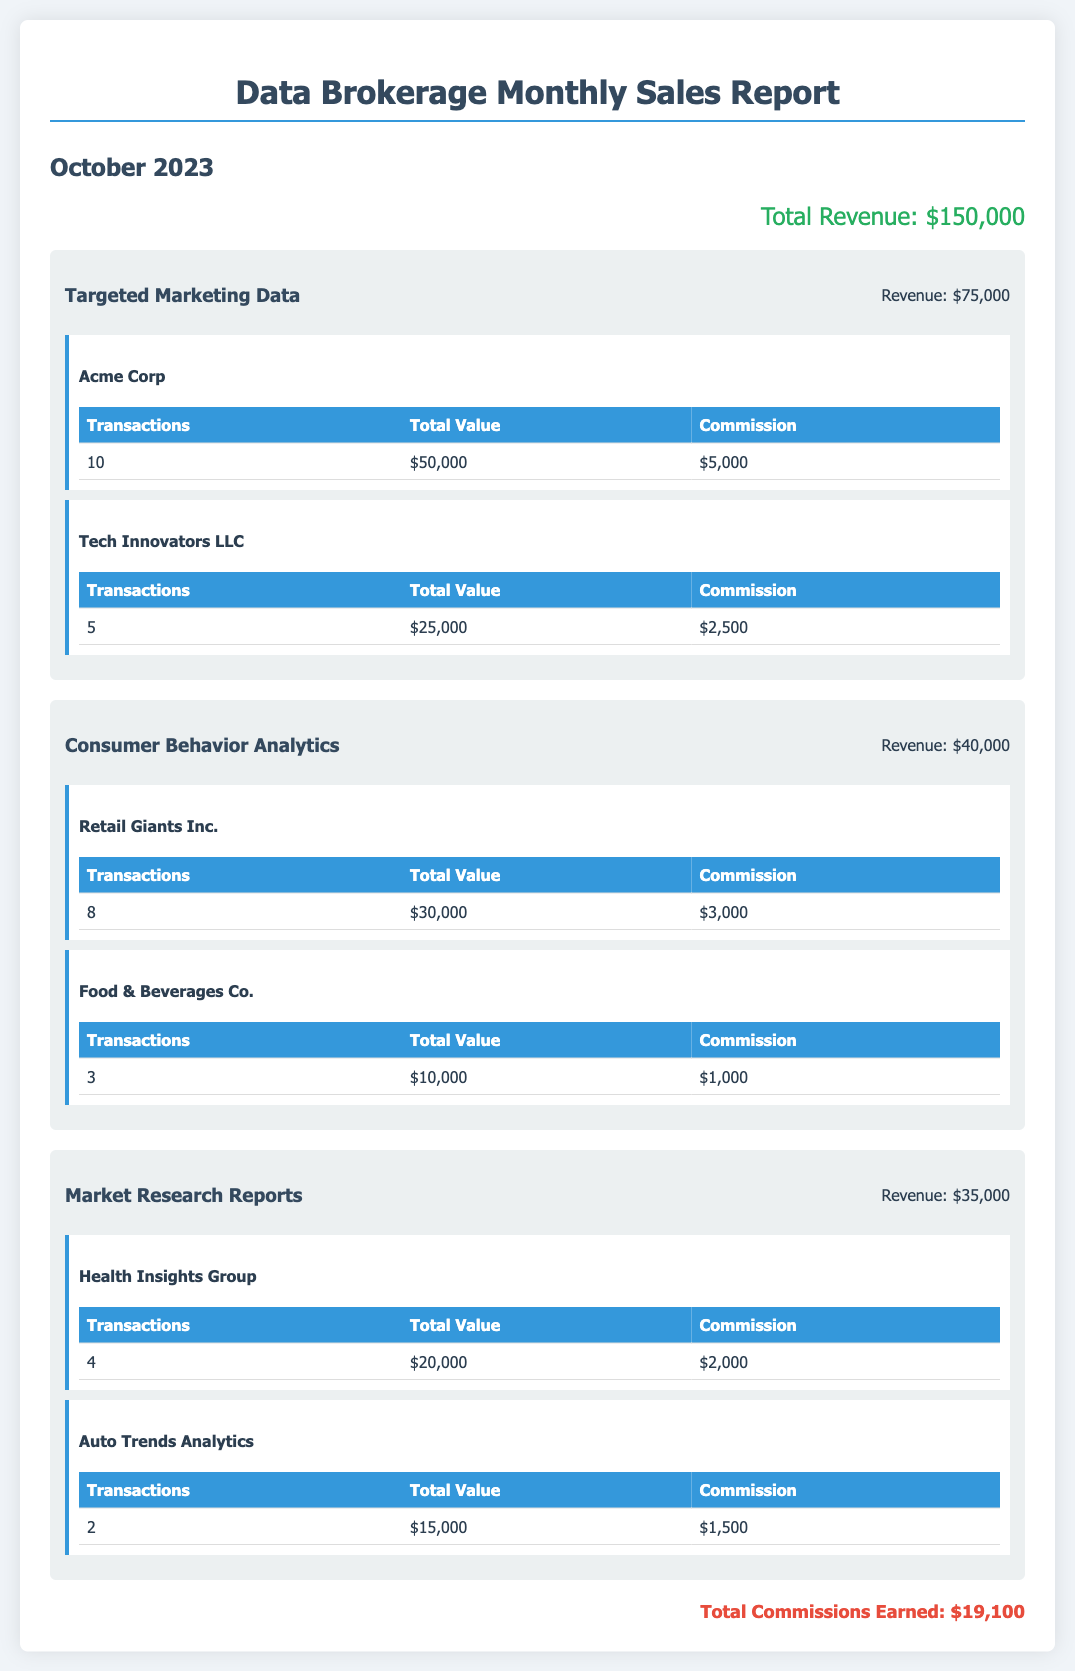what is the total revenue? The total revenue is the overall sum reported at the top of the document, which is $150,000.
Answer: $150,000 how much revenue was generated from Targeted Marketing Data? The revenue for Targeted Marketing Data is indicated in the service section, which states $75,000.
Answer: $75,000 who is the client for Consumer Behavior Analytics with the highest total value? The client with the highest total value under Consumer Behavior Analytics is Retail Giants Inc., with a total value of $30,000.
Answer: Retail Giants Inc what is the commission earned from Acme Corp? The commission earned from Acme Corp is listed in the client section, which states $5,000.
Answer: $5,000 how many transactions were completed for Market Research Reports? The total number of transactions for Market Research Reports is calculated by adding transactions from both clients, which is 4 + 2 = 6.
Answer: 6 what is the total commission earned? The total commission earned is detailed at the bottom of the document, which states $19,100.
Answer: $19,100 which client generated the lowest revenue? The client with the lowest revenue is Food & Beverages Co., generating $10,000.
Answer: Food & Beverages Co what is the total commission earned from Tech Innovators LLC? The commission earned from Tech Innovators LLC is indicated in the client section, which is $2,500.
Answer: $2,500 how many clients are listed under the Targeted Marketing Data service? There are two clients listed under the Targeted Marketing Data service in the client sections.
Answer: 2 